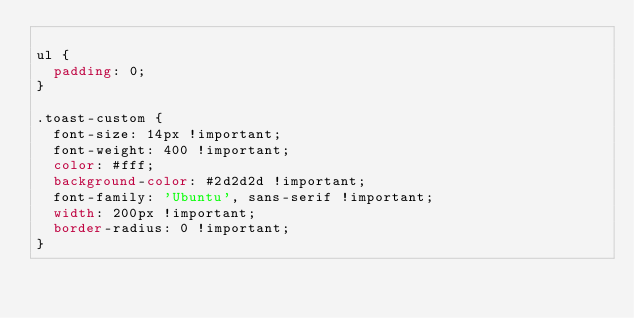<code> <loc_0><loc_0><loc_500><loc_500><_CSS_>
ul {
  padding: 0;
}

.toast-custom {
  font-size: 14px !important;
  font-weight: 400 !important;
  color: #fff;
  background-color: #2d2d2d !important;
  font-family: 'Ubuntu', sans-serif !important;
  width: 200px !important;
  border-radius: 0 !important;
}
</code> 